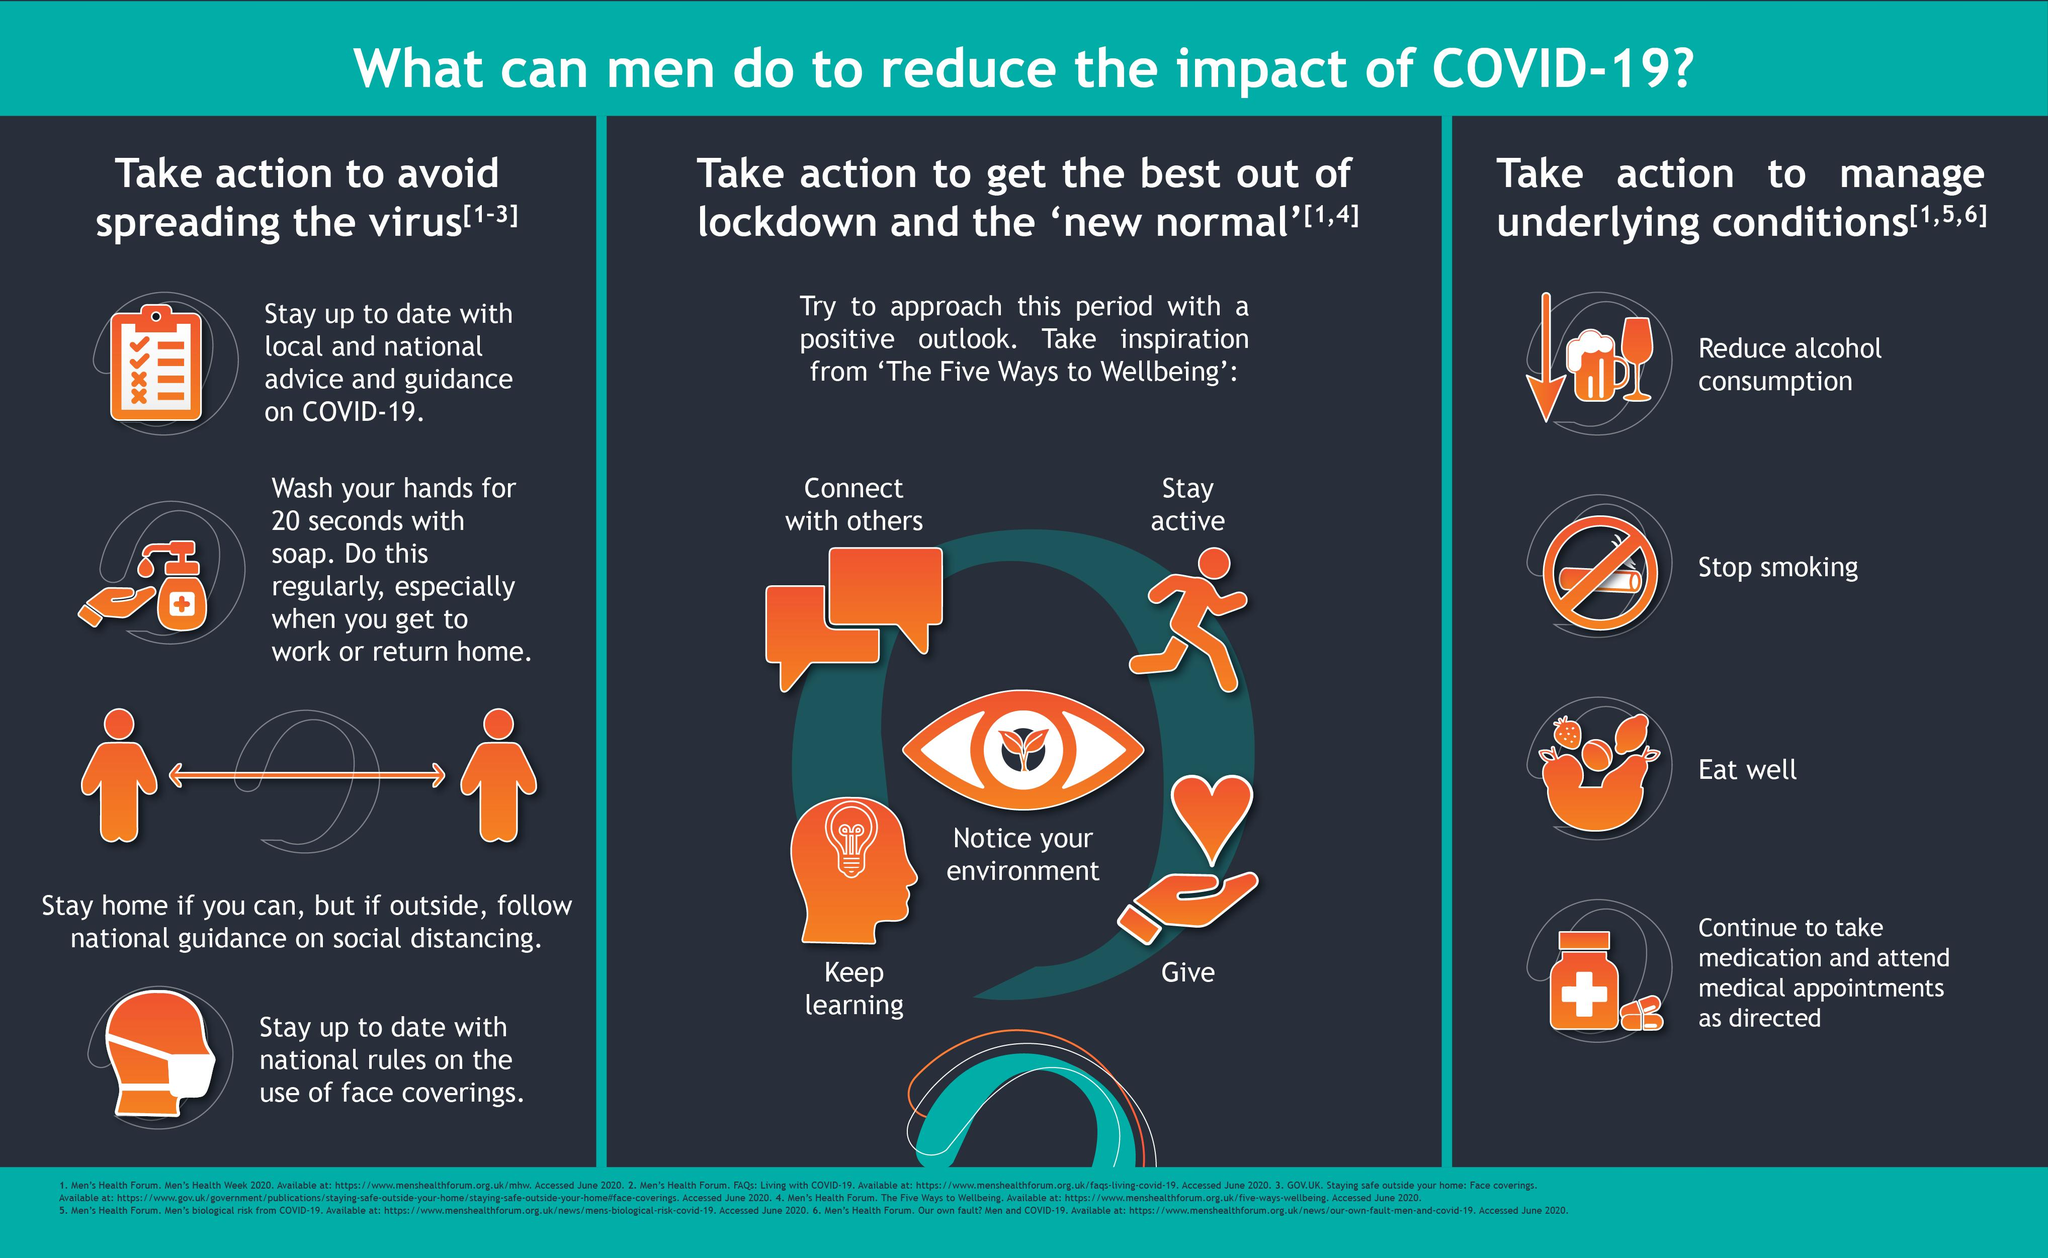Mention a couple of crucial points in this snapshot. Stop smoking is listed as an action point to manage underlying conditions. It is necessary to be connected with others in order to maximize the benefits of Lockdown and adjust to the new normal. Social distancing is crucial to prevent the spread of the virus, as it helps to reduce the risk of exposure and infection. To effectively stay active and maximize the benefits of limited downtime, it is important to follow the recommended action points and adjust to the "new normal. 